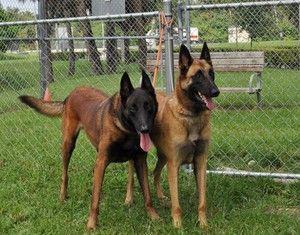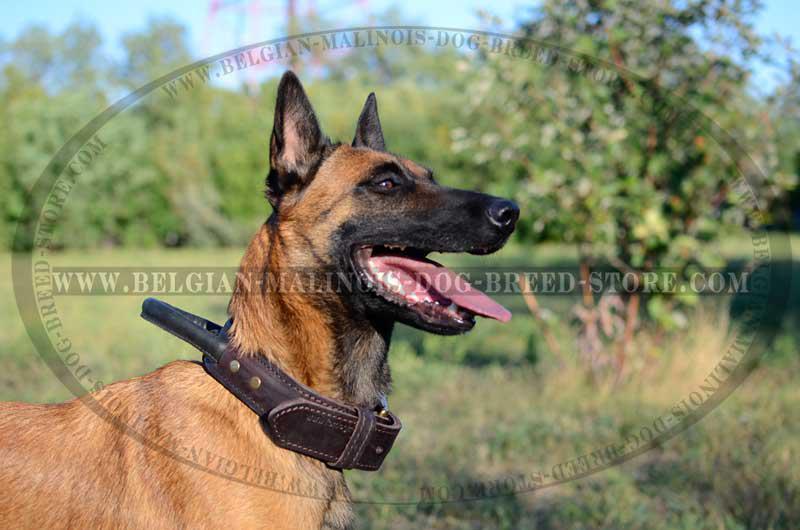The first image is the image on the left, the second image is the image on the right. For the images displayed, is the sentence "One image shows two adult german shepherd dogs posed similarly side-by-side." factually correct? Answer yes or no. Yes. The first image is the image on the left, the second image is the image on the right. Given the left and right images, does the statement "At least one dog is standing near a fence in the image on the left." hold true? Answer yes or no. Yes. 